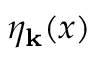Convert formula to latex. <formula><loc_0><loc_0><loc_500><loc_500>\eta _ { k } ( x )</formula> 